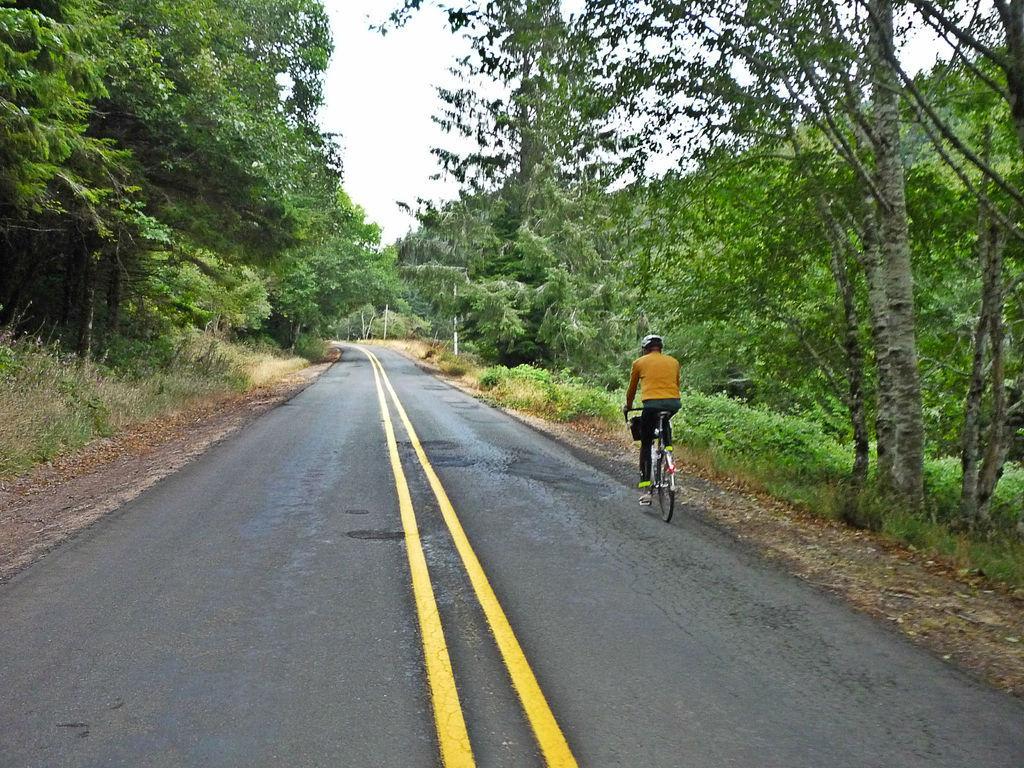Can you describe this image briefly? As we can see in the image there is a road, grass, trees, sky, a man wearing helmet and riding bicycle. 